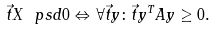<formula> <loc_0><loc_0><loc_500><loc_500>\vec { t } { X } \ p s d 0 \Leftrightarrow \forall \vec { t } { y } \colon \vec { t } { y ^ { T } A y } \geq 0 .</formula> 